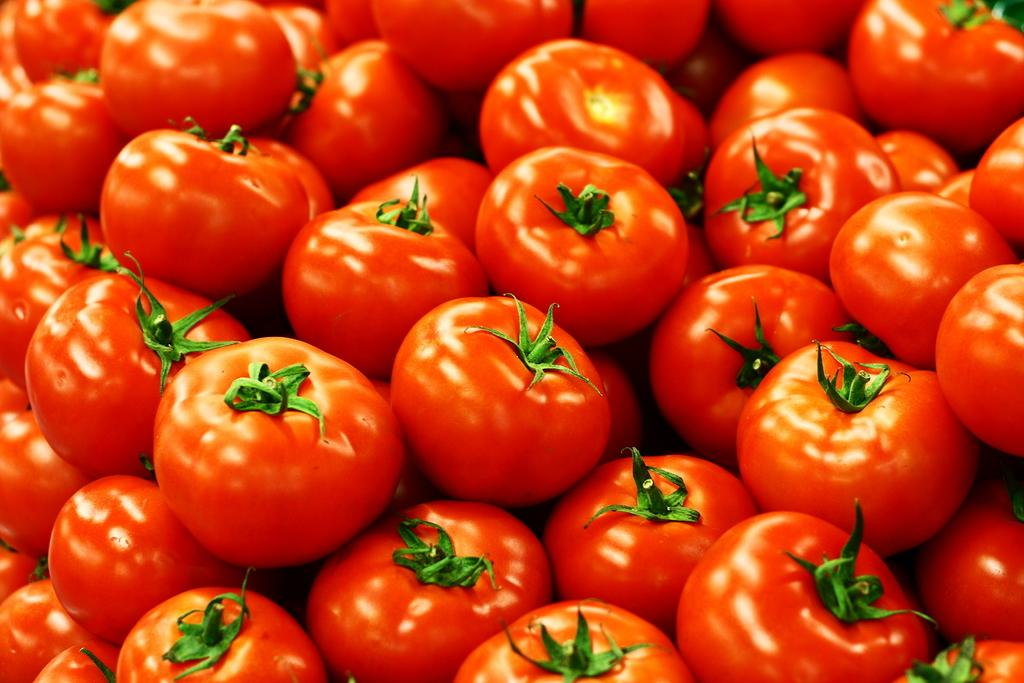What type of fruits are in the image? There is a group of tomatoes in the image. How many tomatoes are in the group? The number of tomatoes in the group cannot be determined from the image alone. What color are the tomatoes? The color of the tomatoes cannot be determined from the image alone, as it may vary depending on their ripeness and variety. What historical event is depicted in the image involving the tomatoes? There is no historical event depicted in the image; it simply shows a group of tomatoes. 